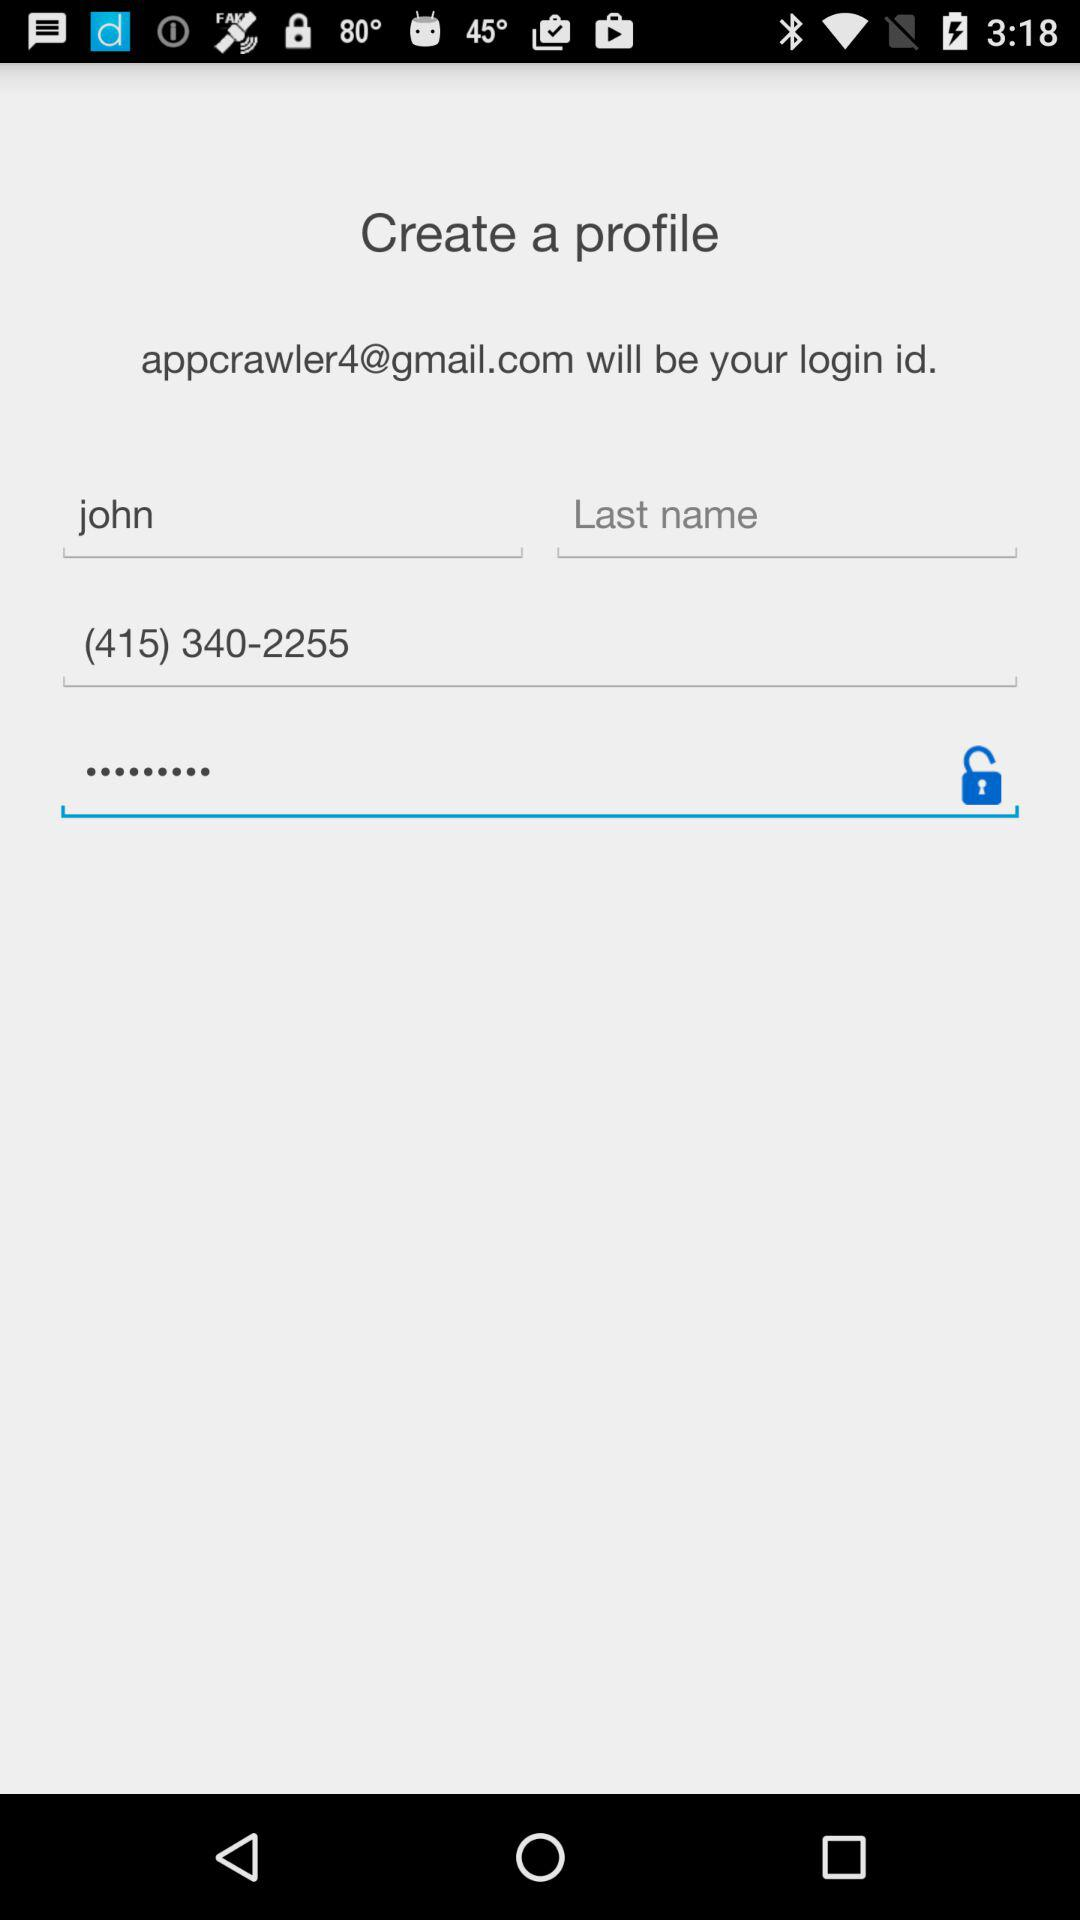What is the email address? The email address is appcrawler4@gmail.com. 